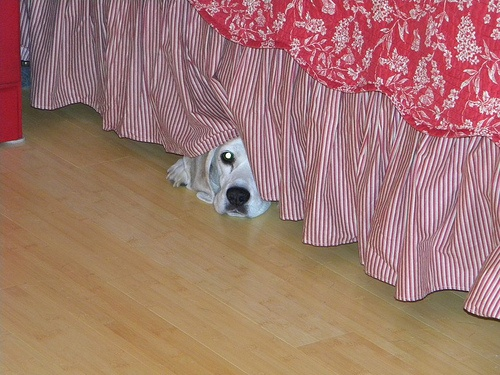Describe the objects in this image and their specific colors. I can see bed in brown, darkgray, and lightpink tones and dog in brown, darkgray, gray, and black tones in this image. 